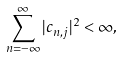<formula> <loc_0><loc_0><loc_500><loc_500>\sum _ { n = - \infty } ^ { \infty } | c _ { n , j } | ^ { 2 } < \infty ,</formula> 